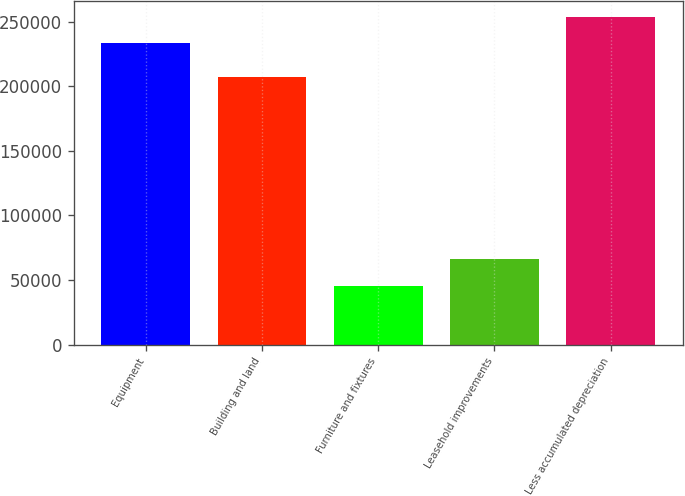<chart> <loc_0><loc_0><loc_500><loc_500><bar_chart><fcel>Equipment<fcel>Building and land<fcel>Furniture and fixtures<fcel>Leasehold improvements<fcel>Less accumulated depreciation<nl><fcel>233140<fcel>207110<fcel>45577<fcel>66108.1<fcel>253671<nl></chart> 